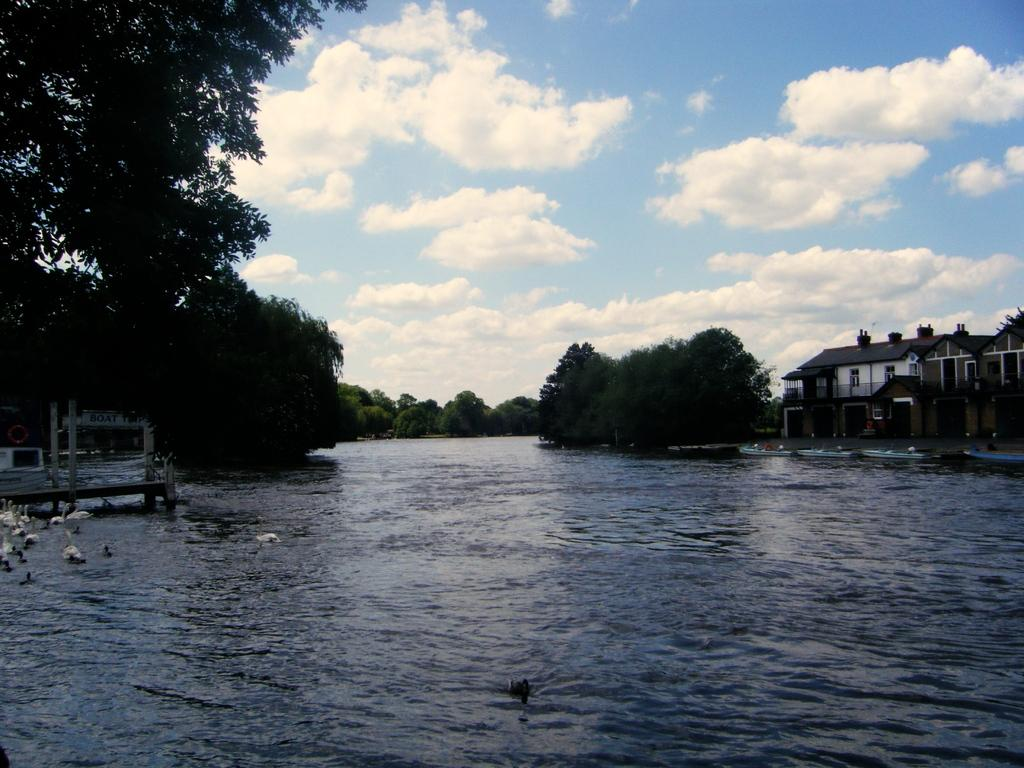What is the main subject of the image? The main subject of the image is water with swans. What can be seen in the background of the image? There are many trees in the background of the image. What type of structure is present in the image? There is a building with walls and roofs in the image. What is visible at the top of the image? The sky with clouds is visible at the top of the image. What letter can be seen floating on the water in the image? There is no letter floating on the water in the image; it only features swans in the water. 